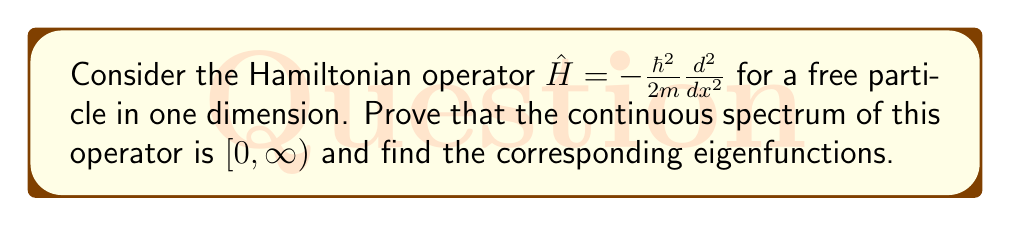Help me with this question. 1. The time-independent Schrödinger equation for this system is:

   $$-\frac{\hbar^2}{2m}\frac{d^2\psi}{dx^2} = E\psi$$

2. Rearrange the equation:

   $$\frac{d^2\psi}{dx^2} + \frac{2mE}{\hbar^2}\psi = 0$$

3. Let $k^2 = \frac{2mE}{\hbar^2}$. The general solution is:

   $$\psi(x) = Ae^{ikx} + Be^{-ikx}$$

4. These solutions exist for all $k \in \mathbb{R}$, which implies $E \geq 0$.

5. The eigenfunctions are not normalizable in the usual sense, as:

   $$\int_{-\infty}^{\infty} |\psi(x)|^2 dx = \infty$$

6. This non-normalizability is a characteristic of continuous spectrum eigenfunctions.

7. The energy eigenvalues form a continuum:

   $$E = \frac{\hbar^2k^2}{2m}, \quad k \in \mathbb{R}$$

8. Therefore, the continuous spectrum is $[0,\infty)$.

9. The eigenfunctions can be written in the form of plane waves:

   $$\psi_k(x) = e^{ikx}, \quad k \in \mathbb{R}$$

These eigenfunctions are orthogonal in the sense of distributions:

   $$\int_{-\infty}^{\infty} \psi_k^*(x)\psi_{k'}(x)dx = 2\pi\delta(k-k')$$

where $\delta(k-k')$ is the Dirac delta function.
Answer: Continuous spectrum: $[0,\infty)$. Eigenfunctions: $\psi_k(x) = e^{ikx}$, $k \in \mathbb{R}$. 